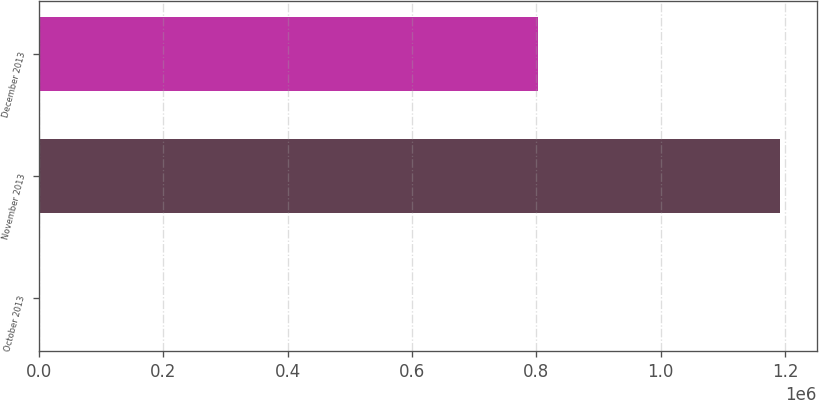<chart> <loc_0><loc_0><loc_500><loc_500><bar_chart><fcel>October 2013<fcel>November 2013<fcel>December 2013<nl><fcel>2.9<fcel>1.19187e+06<fcel>802930<nl></chart> 